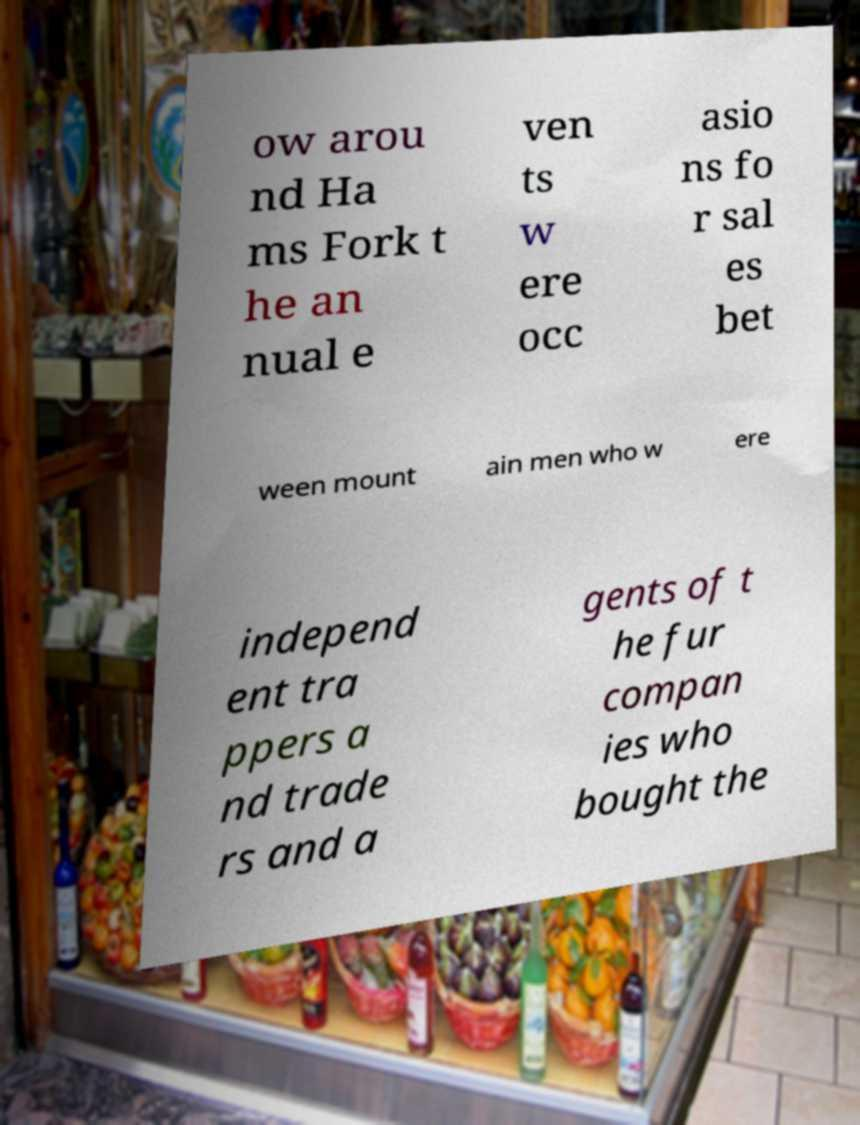Please identify and transcribe the text found in this image. ow arou nd Ha ms Fork t he an nual e ven ts w ere occ asio ns fo r sal es bet ween mount ain men who w ere independ ent tra ppers a nd trade rs and a gents of t he fur compan ies who bought the 